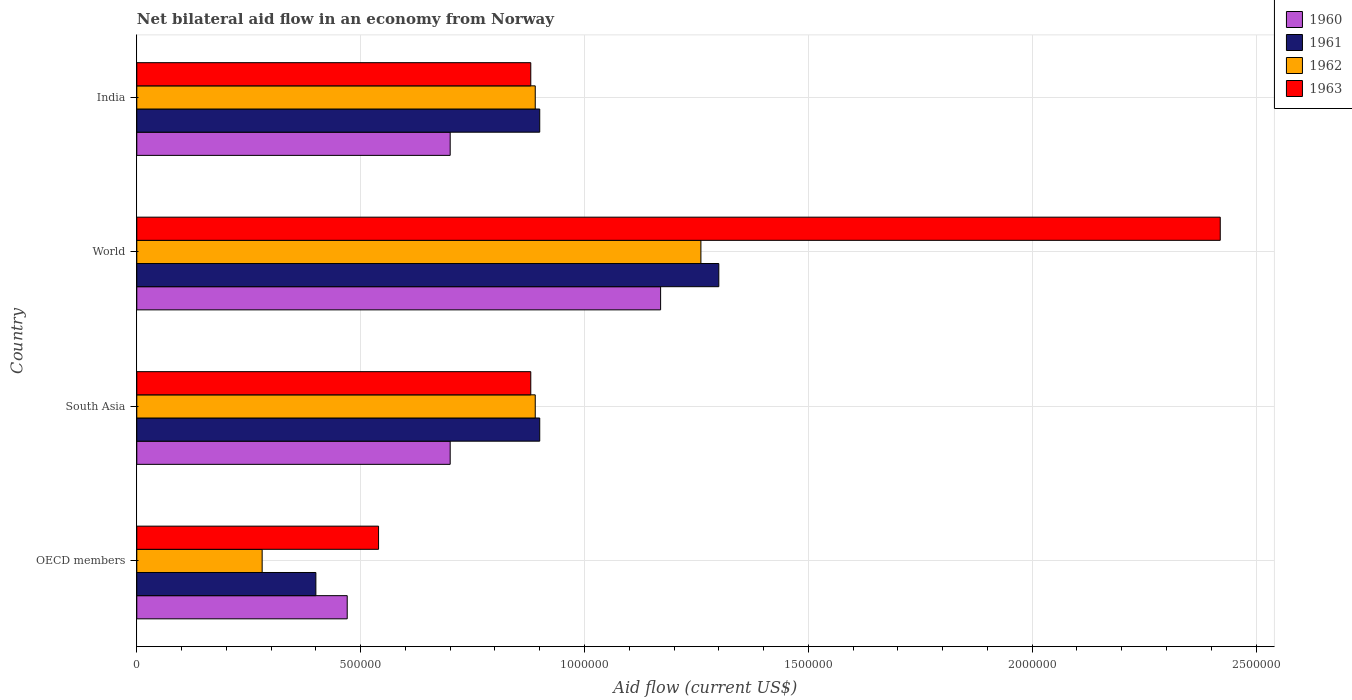How many bars are there on the 3rd tick from the top?
Provide a short and direct response. 4. How many bars are there on the 4th tick from the bottom?
Your answer should be compact. 4. What is the label of the 1st group of bars from the top?
Your response must be concise. India. In how many cases, is the number of bars for a given country not equal to the number of legend labels?
Offer a terse response. 0. What is the net bilateral aid flow in 1962 in India?
Your answer should be compact. 8.90e+05. Across all countries, what is the maximum net bilateral aid flow in 1960?
Offer a terse response. 1.17e+06. In which country was the net bilateral aid flow in 1961 maximum?
Make the answer very short. World. In which country was the net bilateral aid flow in 1963 minimum?
Offer a very short reply. OECD members. What is the total net bilateral aid flow in 1963 in the graph?
Keep it short and to the point. 4.72e+06. What is the difference between the net bilateral aid flow in 1961 in OECD members and that in South Asia?
Offer a very short reply. -5.00e+05. What is the difference between the net bilateral aid flow in 1961 in OECD members and the net bilateral aid flow in 1963 in World?
Your answer should be compact. -2.02e+06. What is the average net bilateral aid flow in 1963 per country?
Provide a succinct answer. 1.18e+06. What is the difference between the net bilateral aid flow in 1963 and net bilateral aid flow in 1962 in India?
Offer a very short reply. -10000. In how many countries, is the net bilateral aid flow in 1960 greater than 1000000 US$?
Ensure brevity in your answer.  1. What is the ratio of the net bilateral aid flow in 1962 in India to that in World?
Provide a short and direct response. 0.71. Is the net bilateral aid flow in 1962 in India less than that in OECD members?
Provide a succinct answer. No. Is the difference between the net bilateral aid flow in 1963 in India and OECD members greater than the difference between the net bilateral aid flow in 1962 in India and OECD members?
Offer a terse response. No. What is the difference between the highest and the lowest net bilateral aid flow in 1963?
Give a very brief answer. 1.88e+06. Is the sum of the net bilateral aid flow in 1961 in India and South Asia greater than the maximum net bilateral aid flow in 1960 across all countries?
Your response must be concise. Yes. Is it the case that in every country, the sum of the net bilateral aid flow in 1961 and net bilateral aid flow in 1962 is greater than the net bilateral aid flow in 1963?
Offer a terse response. Yes. How many bars are there?
Provide a short and direct response. 16. Are all the bars in the graph horizontal?
Offer a terse response. Yes. What is the difference between two consecutive major ticks on the X-axis?
Make the answer very short. 5.00e+05. Are the values on the major ticks of X-axis written in scientific E-notation?
Your answer should be compact. No. Does the graph contain grids?
Give a very brief answer. Yes. Where does the legend appear in the graph?
Give a very brief answer. Top right. How many legend labels are there?
Your answer should be compact. 4. What is the title of the graph?
Keep it short and to the point. Net bilateral aid flow in an economy from Norway. Does "1974" appear as one of the legend labels in the graph?
Provide a succinct answer. No. What is the Aid flow (current US$) in 1961 in OECD members?
Make the answer very short. 4.00e+05. What is the Aid flow (current US$) of 1963 in OECD members?
Provide a succinct answer. 5.40e+05. What is the Aid flow (current US$) in 1960 in South Asia?
Your answer should be compact. 7.00e+05. What is the Aid flow (current US$) of 1962 in South Asia?
Give a very brief answer. 8.90e+05. What is the Aid flow (current US$) in 1963 in South Asia?
Your answer should be compact. 8.80e+05. What is the Aid flow (current US$) in 1960 in World?
Your response must be concise. 1.17e+06. What is the Aid flow (current US$) of 1961 in World?
Provide a short and direct response. 1.30e+06. What is the Aid flow (current US$) of 1962 in World?
Your answer should be very brief. 1.26e+06. What is the Aid flow (current US$) in 1963 in World?
Offer a very short reply. 2.42e+06. What is the Aid flow (current US$) in 1960 in India?
Provide a short and direct response. 7.00e+05. What is the Aid flow (current US$) of 1961 in India?
Provide a short and direct response. 9.00e+05. What is the Aid flow (current US$) of 1962 in India?
Provide a succinct answer. 8.90e+05. What is the Aid flow (current US$) of 1963 in India?
Give a very brief answer. 8.80e+05. Across all countries, what is the maximum Aid flow (current US$) of 1960?
Your answer should be compact. 1.17e+06. Across all countries, what is the maximum Aid flow (current US$) in 1961?
Your answer should be compact. 1.30e+06. Across all countries, what is the maximum Aid flow (current US$) in 1962?
Your answer should be compact. 1.26e+06. Across all countries, what is the maximum Aid flow (current US$) in 1963?
Provide a succinct answer. 2.42e+06. Across all countries, what is the minimum Aid flow (current US$) in 1963?
Your answer should be very brief. 5.40e+05. What is the total Aid flow (current US$) in 1960 in the graph?
Your answer should be very brief. 3.04e+06. What is the total Aid flow (current US$) of 1961 in the graph?
Make the answer very short. 3.50e+06. What is the total Aid flow (current US$) in 1962 in the graph?
Provide a short and direct response. 3.32e+06. What is the total Aid flow (current US$) in 1963 in the graph?
Make the answer very short. 4.72e+06. What is the difference between the Aid flow (current US$) of 1961 in OECD members and that in South Asia?
Make the answer very short. -5.00e+05. What is the difference between the Aid flow (current US$) of 1962 in OECD members and that in South Asia?
Your answer should be compact. -6.10e+05. What is the difference between the Aid flow (current US$) of 1960 in OECD members and that in World?
Your answer should be very brief. -7.00e+05. What is the difference between the Aid flow (current US$) in 1961 in OECD members and that in World?
Keep it short and to the point. -9.00e+05. What is the difference between the Aid flow (current US$) in 1962 in OECD members and that in World?
Your response must be concise. -9.80e+05. What is the difference between the Aid flow (current US$) of 1963 in OECD members and that in World?
Keep it short and to the point. -1.88e+06. What is the difference between the Aid flow (current US$) of 1961 in OECD members and that in India?
Ensure brevity in your answer.  -5.00e+05. What is the difference between the Aid flow (current US$) in 1962 in OECD members and that in India?
Provide a short and direct response. -6.10e+05. What is the difference between the Aid flow (current US$) in 1963 in OECD members and that in India?
Your answer should be compact. -3.40e+05. What is the difference between the Aid flow (current US$) of 1960 in South Asia and that in World?
Provide a short and direct response. -4.70e+05. What is the difference between the Aid flow (current US$) of 1961 in South Asia and that in World?
Offer a terse response. -4.00e+05. What is the difference between the Aid flow (current US$) of 1962 in South Asia and that in World?
Ensure brevity in your answer.  -3.70e+05. What is the difference between the Aid flow (current US$) in 1963 in South Asia and that in World?
Your answer should be compact. -1.54e+06. What is the difference between the Aid flow (current US$) in 1960 in South Asia and that in India?
Your answer should be compact. 0. What is the difference between the Aid flow (current US$) in 1960 in World and that in India?
Provide a succinct answer. 4.70e+05. What is the difference between the Aid flow (current US$) of 1963 in World and that in India?
Offer a terse response. 1.54e+06. What is the difference between the Aid flow (current US$) of 1960 in OECD members and the Aid flow (current US$) of 1961 in South Asia?
Make the answer very short. -4.30e+05. What is the difference between the Aid flow (current US$) of 1960 in OECD members and the Aid flow (current US$) of 1962 in South Asia?
Provide a short and direct response. -4.20e+05. What is the difference between the Aid flow (current US$) in 1960 in OECD members and the Aid flow (current US$) in 1963 in South Asia?
Provide a succinct answer. -4.10e+05. What is the difference between the Aid flow (current US$) of 1961 in OECD members and the Aid flow (current US$) of 1962 in South Asia?
Your answer should be compact. -4.90e+05. What is the difference between the Aid flow (current US$) in 1961 in OECD members and the Aid flow (current US$) in 1963 in South Asia?
Provide a short and direct response. -4.80e+05. What is the difference between the Aid flow (current US$) in 1962 in OECD members and the Aid flow (current US$) in 1963 in South Asia?
Offer a very short reply. -6.00e+05. What is the difference between the Aid flow (current US$) in 1960 in OECD members and the Aid flow (current US$) in 1961 in World?
Offer a very short reply. -8.30e+05. What is the difference between the Aid flow (current US$) of 1960 in OECD members and the Aid flow (current US$) of 1962 in World?
Your answer should be compact. -7.90e+05. What is the difference between the Aid flow (current US$) in 1960 in OECD members and the Aid flow (current US$) in 1963 in World?
Provide a short and direct response. -1.95e+06. What is the difference between the Aid flow (current US$) of 1961 in OECD members and the Aid flow (current US$) of 1962 in World?
Provide a succinct answer. -8.60e+05. What is the difference between the Aid flow (current US$) in 1961 in OECD members and the Aid flow (current US$) in 1963 in World?
Keep it short and to the point. -2.02e+06. What is the difference between the Aid flow (current US$) of 1962 in OECD members and the Aid flow (current US$) of 1963 in World?
Your answer should be very brief. -2.14e+06. What is the difference between the Aid flow (current US$) of 1960 in OECD members and the Aid flow (current US$) of 1961 in India?
Your response must be concise. -4.30e+05. What is the difference between the Aid flow (current US$) of 1960 in OECD members and the Aid flow (current US$) of 1962 in India?
Keep it short and to the point. -4.20e+05. What is the difference between the Aid flow (current US$) in 1960 in OECD members and the Aid flow (current US$) in 1963 in India?
Provide a short and direct response. -4.10e+05. What is the difference between the Aid flow (current US$) in 1961 in OECD members and the Aid flow (current US$) in 1962 in India?
Your answer should be very brief. -4.90e+05. What is the difference between the Aid flow (current US$) in 1961 in OECD members and the Aid flow (current US$) in 1963 in India?
Make the answer very short. -4.80e+05. What is the difference between the Aid flow (current US$) of 1962 in OECD members and the Aid flow (current US$) of 1963 in India?
Keep it short and to the point. -6.00e+05. What is the difference between the Aid flow (current US$) of 1960 in South Asia and the Aid flow (current US$) of 1961 in World?
Provide a short and direct response. -6.00e+05. What is the difference between the Aid flow (current US$) in 1960 in South Asia and the Aid flow (current US$) in 1962 in World?
Your response must be concise. -5.60e+05. What is the difference between the Aid flow (current US$) in 1960 in South Asia and the Aid flow (current US$) in 1963 in World?
Offer a very short reply. -1.72e+06. What is the difference between the Aid flow (current US$) of 1961 in South Asia and the Aid flow (current US$) of 1962 in World?
Provide a short and direct response. -3.60e+05. What is the difference between the Aid flow (current US$) of 1961 in South Asia and the Aid flow (current US$) of 1963 in World?
Provide a succinct answer. -1.52e+06. What is the difference between the Aid flow (current US$) in 1962 in South Asia and the Aid flow (current US$) in 1963 in World?
Keep it short and to the point. -1.53e+06. What is the difference between the Aid flow (current US$) in 1960 in South Asia and the Aid flow (current US$) in 1961 in India?
Keep it short and to the point. -2.00e+05. What is the difference between the Aid flow (current US$) of 1960 in South Asia and the Aid flow (current US$) of 1962 in India?
Provide a short and direct response. -1.90e+05. What is the difference between the Aid flow (current US$) in 1960 in World and the Aid flow (current US$) in 1962 in India?
Keep it short and to the point. 2.80e+05. What is the difference between the Aid flow (current US$) in 1961 in World and the Aid flow (current US$) in 1962 in India?
Provide a succinct answer. 4.10e+05. What is the average Aid flow (current US$) in 1960 per country?
Your response must be concise. 7.60e+05. What is the average Aid flow (current US$) of 1961 per country?
Keep it short and to the point. 8.75e+05. What is the average Aid flow (current US$) of 1962 per country?
Your response must be concise. 8.30e+05. What is the average Aid flow (current US$) in 1963 per country?
Give a very brief answer. 1.18e+06. What is the difference between the Aid flow (current US$) in 1960 and Aid flow (current US$) in 1961 in OECD members?
Your answer should be very brief. 7.00e+04. What is the difference between the Aid flow (current US$) of 1961 and Aid flow (current US$) of 1962 in OECD members?
Your answer should be compact. 1.20e+05. What is the difference between the Aid flow (current US$) in 1962 and Aid flow (current US$) in 1963 in OECD members?
Your answer should be very brief. -2.60e+05. What is the difference between the Aid flow (current US$) of 1960 and Aid flow (current US$) of 1961 in South Asia?
Offer a very short reply. -2.00e+05. What is the difference between the Aid flow (current US$) of 1960 and Aid flow (current US$) of 1962 in South Asia?
Ensure brevity in your answer.  -1.90e+05. What is the difference between the Aid flow (current US$) of 1960 and Aid flow (current US$) of 1963 in South Asia?
Make the answer very short. -1.80e+05. What is the difference between the Aid flow (current US$) in 1960 and Aid flow (current US$) in 1962 in World?
Provide a short and direct response. -9.00e+04. What is the difference between the Aid flow (current US$) in 1960 and Aid flow (current US$) in 1963 in World?
Provide a short and direct response. -1.25e+06. What is the difference between the Aid flow (current US$) in 1961 and Aid flow (current US$) in 1963 in World?
Ensure brevity in your answer.  -1.12e+06. What is the difference between the Aid flow (current US$) in 1962 and Aid flow (current US$) in 1963 in World?
Make the answer very short. -1.16e+06. What is the difference between the Aid flow (current US$) in 1960 and Aid flow (current US$) in 1963 in India?
Offer a very short reply. -1.80e+05. What is the difference between the Aid flow (current US$) in 1961 and Aid flow (current US$) in 1963 in India?
Offer a very short reply. 2.00e+04. What is the difference between the Aid flow (current US$) of 1962 and Aid flow (current US$) of 1963 in India?
Provide a short and direct response. 10000. What is the ratio of the Aid flow (current US$) in 1960 in OECD members to that in South Asia?
Your answer should be compact. 0.67. What is the ratio of the Aid flow (current US$) of 1961 in OECD members to that in South Asia?
Offer a terse response. 0.44. What is the ratio of the Aid flow (current US$) in 1962 in OECD members to that in South Asia?
Provide a succinct answer. 0.31. What is the ratio of the Aid flow (current US$) in 1963 in OECD members to that in South Asia?
Make the answer very short. 0.61. What is the ratio of the Aid flow (current US$) of 1960 in OECD members to that in World?
Provide a succinct answer. 0.4. What is the ratio of the Aid flow (current US$) in 1961 in OECD members to that in World?
Give a very brief answer. 0.31. What is the ratio of the Aid flow (current US$) of 1962 in OECD members to that in World?
Keep it short and to the point. 0.22. What is the ratio of the Aid flow (current US$) in 1963 in OECD members to that in World?
Your response must be concise. 0.22. What is the ratio of the Aid flow (current US$) of 1960 in OECD members to that in India?
Give a very brief answer. 0.67. What is the ratio of the Aid flow (current US$) in 1961 in OECD members to that in India?
Your answer should be compact. 0.44. What is the ratio of the Aid flow (current US$) of 1962 in OECD members to that in India?
Provide a succinct answer. 0.31. What is the ratio of the Aid flow (current US$) of 1963 in OECD members to that in India?
Keep it short and to the point. 0.61. What is the ratio of the Aid flow (current US$) in 1960 in South Asia to that in World?
Ensure brevity in your answer.  0.6. What is the ratio of the Aid flow (current US$) in 1961 in South Asia to that in World?
Make the answer very short. 0.69. What is the ratio of the Aid flow (current US$) in 1962 in South Asia to that in World?
Make the answer very short. 0.71. What is the ratio of the Aid flow (current US$) in 1963 in South Asia to that in World?
Provide a short and direct response. 0.36. What is the ratio of the Aid flow (current US$) in 1960 in South Asia to that in India?
Offer a terse response. 1. What is the ratio of the Aid flow (current US$) of 1962 in South Asia to that in India?
Offer a terse response. 1. What is the ratio of the Aid flow (current US$) in 1963 in South Asia to that in India?
Your answer should be very brief. 1. What is the ratio of the Aid flow (current US$) of 1960 in World to that in India?
Your answer should be very brief. 1.67. What is the ratio of the Aid flow (current US$) of 1961 in World to that in India?
Your answer should be compact. 1.44. What is the ratio of the Aid flow (current US$) of 1962 in World to that in India?
Your answer should be compact. 1.42. What is the ratio of the Aid flow (current US$) in 1963 in World to that in India?
Provide a short and direct response. 2.75. What is the difference between the highest and the second highest Aid flow (current US$) in 1960?
Give a very brief answer. 4.70e+05. What is the difference between the highest and the second highest Aid flow (current US$) of 1963?
Ensure brevity in your answer.  1.54e+06. What is the difference between the highest and the lowest Aid flow (current US$) of 1960?
Your response must be concise. 7.00e+05. What is the difference between the highest and the lowest Aid flow (current US$) in 1961?
Offer a terse response. 9.00e+05. What is the difference between the highest and the lowest Aid flow (current US$) in 1962?
Your answer should be very brief. 9.80e+05. What is the difference between the highest and the lowest Aid flow (current US$) of 1963?
Provide a succinct answer. 1.88e+06. 